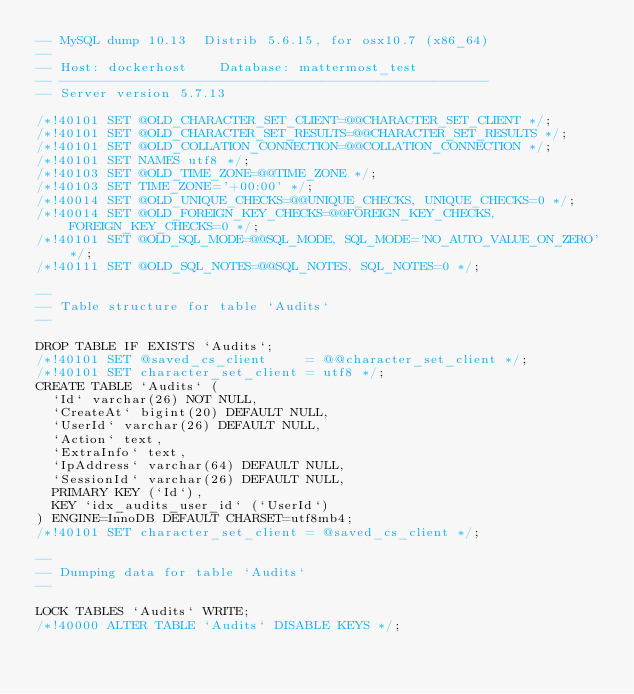Convert code to text. <code><loc_0><loc_0><loc_500><loc_500><_SQL_>-- MySQL dump 10.13  Distrib 5.6.15, for osx10.7 (x86_64)
--
-- Host: dockerhost    Database: mattermost_test
-- ------------------------------------------------------
-- Server version	5.7.13

/*!40101 SET @OLD_CHARACTER_SET_CLIENT=@@CHARACTER_SET_CLIENT */;
/*!40101 SET @OLD_CHARACTER_SET_RESULTS=@@CHARACTER_SET_RESULTS */;
/*!40101 SET @OLD_COLLATION_CONNECTION=@@COLLATION_CONNECTION */;
/*!40101 SET NAMES utf8 */;
/*!40103 SET @OLD_TIME_ZONE=@@TIME_ZONE */;
/*!40103 SET TIME_ZONE='+00:00' */;
/*!40014 SET @OLD_UNIQUE_CHECKS=@@UNIQUE_CHECKS, UNIQUE_CHECKS=0 */;
/*!40014 SET @OLD_FOREIGN_KEY_CHECKS=@@FOREIGN_KEY_CHECKS, FOREIGN_KEY_CHECKS=0 */;
/*!40101 SET @OLD_SQL_MODE=@@SQL_MODE, SQL_MODE='NO_AUTO_VALUE_ON_ZERO' */;
/*!40111 SET @OLD_SQL_NOTES=@@SQL_NOTES, SQL_NOTES=0 */;

--
-- Table structure for table `Audits`
--

DROP TABLE IF EXISTS `Audits`;
/*!40101 SET @saved_cs_client     = @@character_set_client */;
/*!40101 SET character_set_client = utf8 */;
CREATE TABLE `Audits` (
  `Id` varchar(26) NOT NULL,
  `CreateAt` bigint(20) DEFAULT NULL,
  `UserId` varchar(26) DEFAULT NULL,
  `Action` text,
  `ExtraInfo` text,
  `IpAddress` varchar(64) DEFAULT NULL,
  `SessionId` varchar(26) DEFAULT NULL,
  PRIMARY KEY (`Id`),
  KEY `idx_audits_user_id` (`UserId`)
) ENGINE=InnoDB DEFAULT CHARSET=utf8mb4;
/*!40101 SET character_set_client = @saved_cs_client */;

--
-- Dumping data for table `Audits`
--

LOCK TABLES `Audits` WRITE;
/*!40000 ALTER TABLE `Audits` DISABLE KEYS */;</code> 